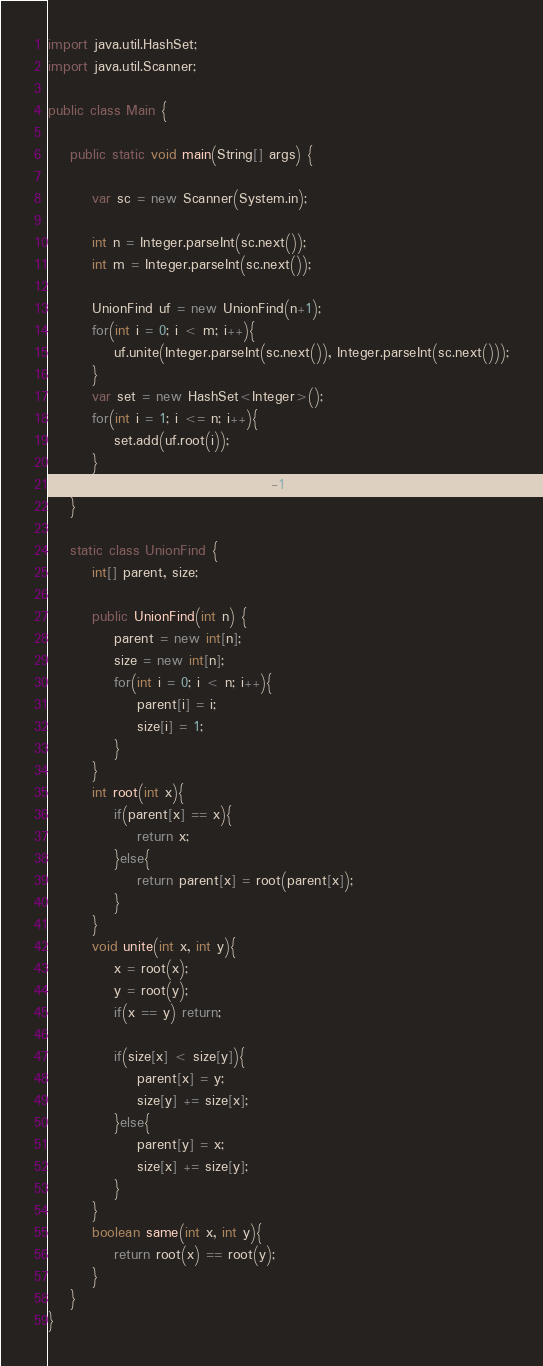Convert code to text. <code><loc_0><loc_0><loc_500><loc_500><_Java_>import java.util.HashSet;
import java.util.Scanner;

public class Main {

    public static void main(String[] args) {
    
        var sc = new Scanner(System.in);
        
        int n = Integer.parseInt(sc.next());
        int m = Integer.parseInt(sc.next());
        
        UnionFind uf = new UnionFind(n+1);
        for(int i = 0; i < m; i++){
            uf.unite(Integer.parseInt(sc.next()), Integer.parseInt(sc.next()));
        }
        var set = new HashSet<Integer>();
        for(int i = 1; i <= n; i++){
            set.add(uf.root(i));
        }
        System.out.println(set.size() -1);
    }
    
    static class UnionFind {
        int[] parent, size;
        
        public UnionFind(int n) {
            parent = new int[n];
            size = new int[n];
            for(int i = 0; i < n; i++){
                parent[i] = i;
                size[i] = 1;
            }
        }
        int root(int x){
            if(parent[x] == x){
                return x;
            }else{
                return parent[x] = root(parent[x]);
            }
        }
        void unite(int x, int y){
            x = root(x);
            y = root(y);
            if(x == y) return;
            
            if(size[x] < size[y]){
                parent[x] = y;
                size[y] += size[x];
            }else{
                parent[y] = x;
                size[x] += size[y];
            }
        }
        boolean same(int x, int y){
            return root(x) == root(y);
        }
    }
}</code> 